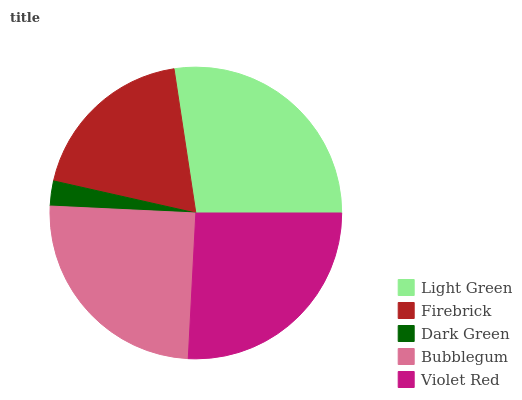Is Dark Green the minimum?
Answer yes or no. Yes. Is Light Green the maximum?
Answer yes or no. Yes. Is Firebrick the minimum?
Answer yes or no. No. Is Firebrick the maximum?
Answer yes or no. No. Is Light Green greater than Firebrick?
Answer yes or no. Yes. Is Firebrick less than Light Green?
Answer yes or no. Yes. Is Firebrick greater than Light Green?
Answer yes or no. No. Is Light Green less than Firebrick?
Answer yes or no. No. Is Bubblegum the high median?
Answer yes or no. Yes. Is Bubblegum the low median?
Answer yes or no. Yes. Is Dark Green the high median?
Answer yes or no. No. Is Firebrick the low median?
Answer yes or no. No. 